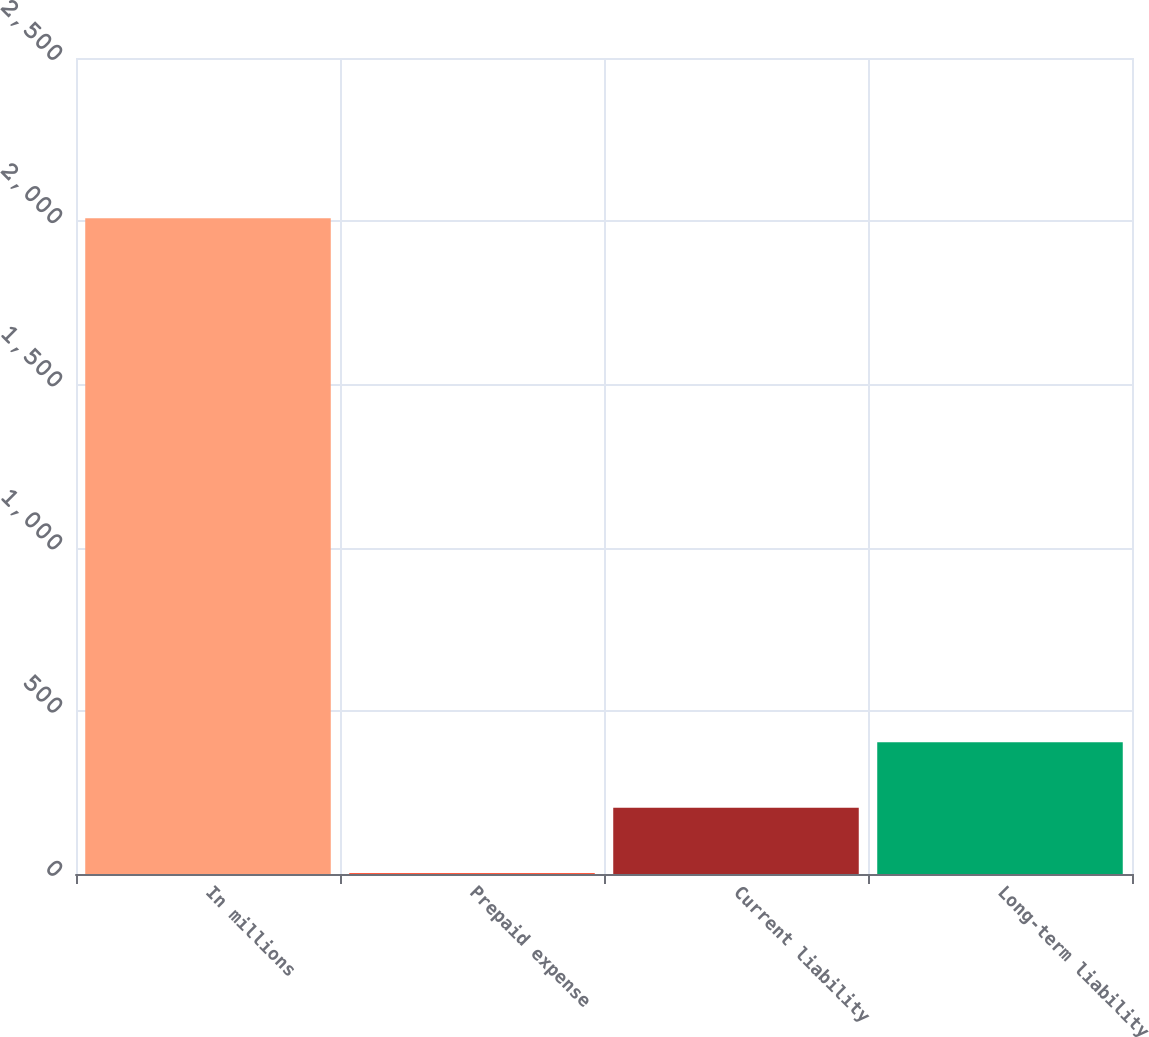Convert chart. <chart><loc_0><loc_0><loc_500><loc_500><bar_chart><fcel>In millions<fcel>Prepaid expense<fcel>Current liability<fcel>Long-term liability<nl><fcel>2009<fcel>2.5<fcel>203.15<fcel>403.8<nl></chart> 